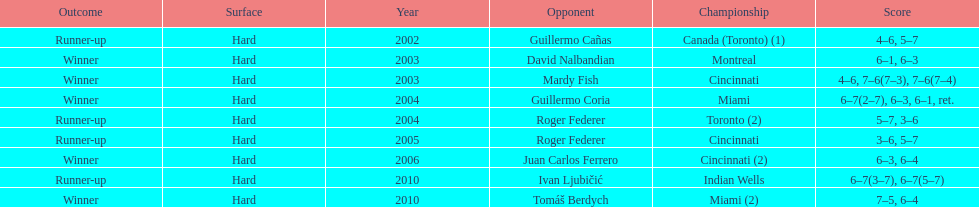How many total wins has he had? 5. 